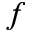Convert formula to latex. <formula><loc_0><loc_0><loc_500><loc_500>f</formula> 